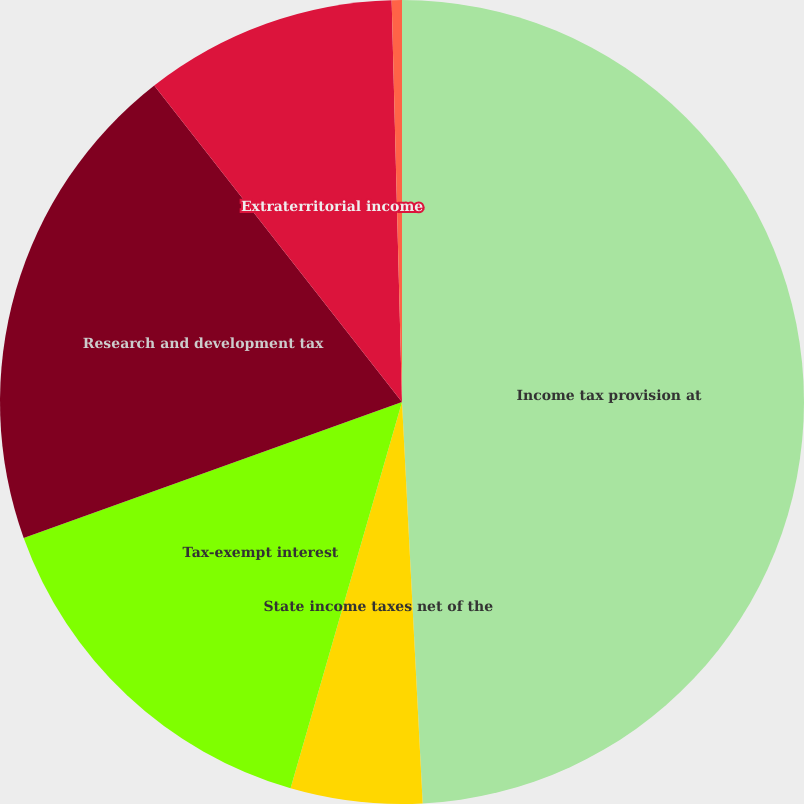Convert chart to OTSL. <chart><loc_0><loc_0><loc_500><loc_500><pie_chart><fcel>Income tax provision at<fcel>State income taxes net of the<fcel>Tax-exempt interest<fcel>Research and development tax<fcel>Extraterritorial income<fcel>Other<nl><fcel>49.18%<fcel>5.29%<fcel>15.04%<fcel>19.92%<fcel>10.16%<fcel>0.41%<nl></chart> 